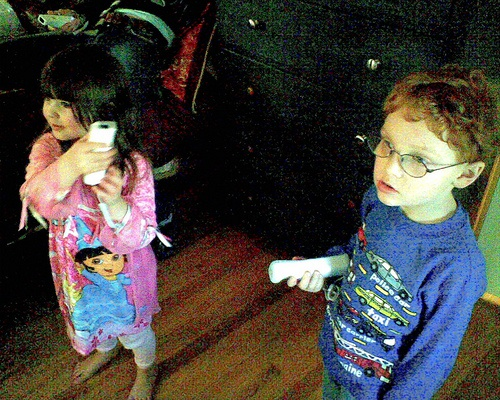Describe the objects in this image and their specific colors. I can see people in olive, black, beige, gray, and blue tones, people in olive, black, lightpink, white, and khaki tones, remote in olive, white, lightblue, darkgray, and lightgreen tones, and remote in olive, white, khaki, lightgreen, and darkgray tones in this image. 